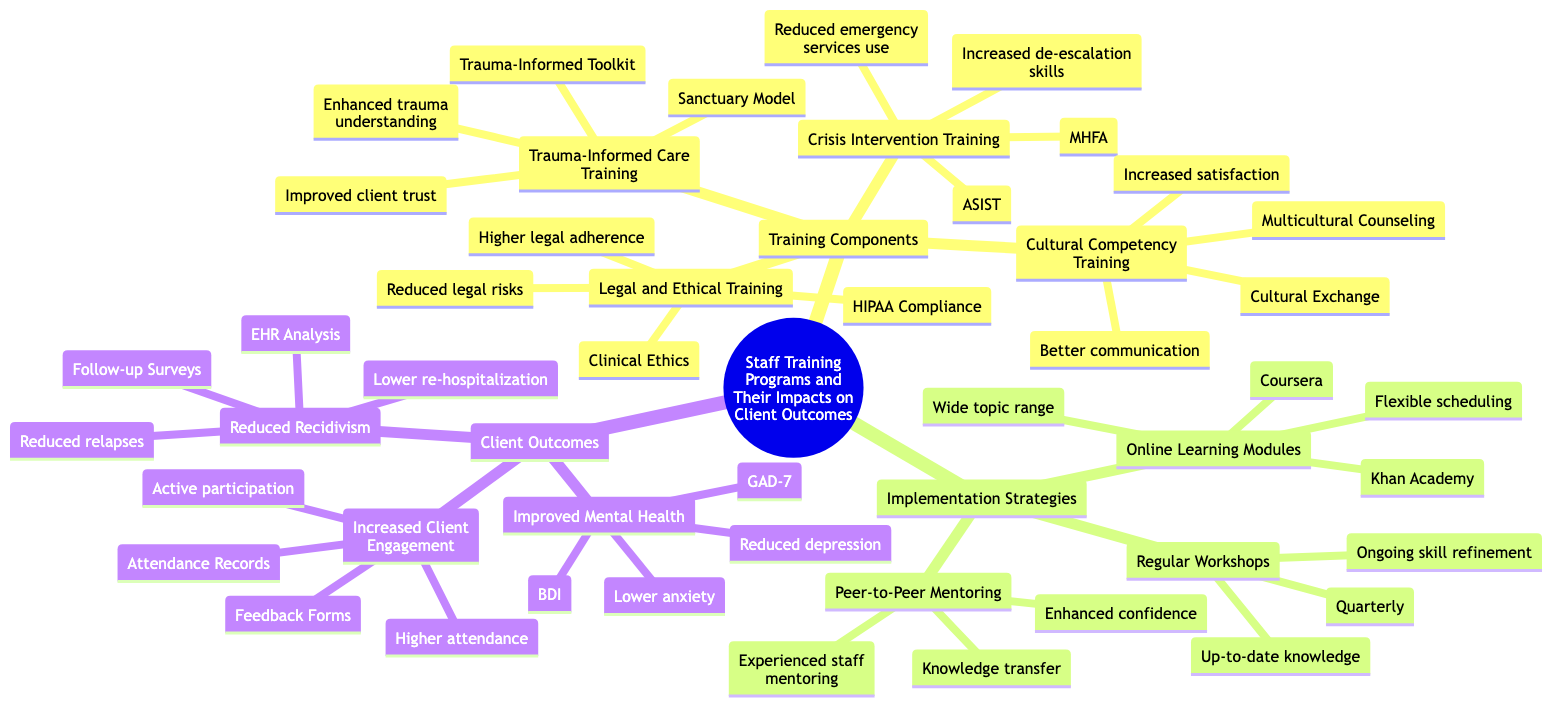What are the examples of crisis intervention training? The node for Crisis Intervention Training lists two examples: Applied Suicide Intervention Skills Training (ASIST) and Mental Health First Aid (MHFA).
Answer: ASIST, MHFA How often are regular workshops held? Looking at the Implementation Strategies section, it states that regular workshops are held quarterly.
Answer: Quarterly What is the benefit of peer-to-peer mentoring? The node for Peer-to-Peer Mentoring lists two benefits: knowledge transfer and enhanced confidence among new hires.
Answer: Knowledge transfer, enhanced confidence Which training component focuses on legal standards? In the Training Components section, the Legal and Ethical Training component specifically addresses adherence to legal standards.
Answer: Legal and Ethical Training What client outcome metrics are used to measure improved mental health? The metrics listed under Improved Mental Health include reduction in depressive symptoms and lower anxiety scores.
Answer: Reduction in depressive symptoms, lower anxiety scores What is the impact of Cultural Competency Training on client satisfaction? The Cultural Competency Training node indicates that one of its impacts is increased client satisfaction.
Answer: Increased client satisfaction How many training components are mentioned in the diagram? Counting the nodes under Training Components, there are four training areas: Crisis Intervention Training, Trauma-Informed Care Training, Cultural Competency Training, and Legal and Ethical Training.
Answer: Four What type of training has the impact of enhanced understanding of client trauma? The Training Component that includes the impact of enhanced understanding of client trauma is Trauma-Informed Care Training.
Answer: Trauma-Informed Care Training Which measurement tool is used to assess lower anxiety scores? The diagram lists the Generalized Anxiety Disorder 7 (GAD-7) as a measurement tool for evaluating lower anxiety scores.
Answer: GAD-7 